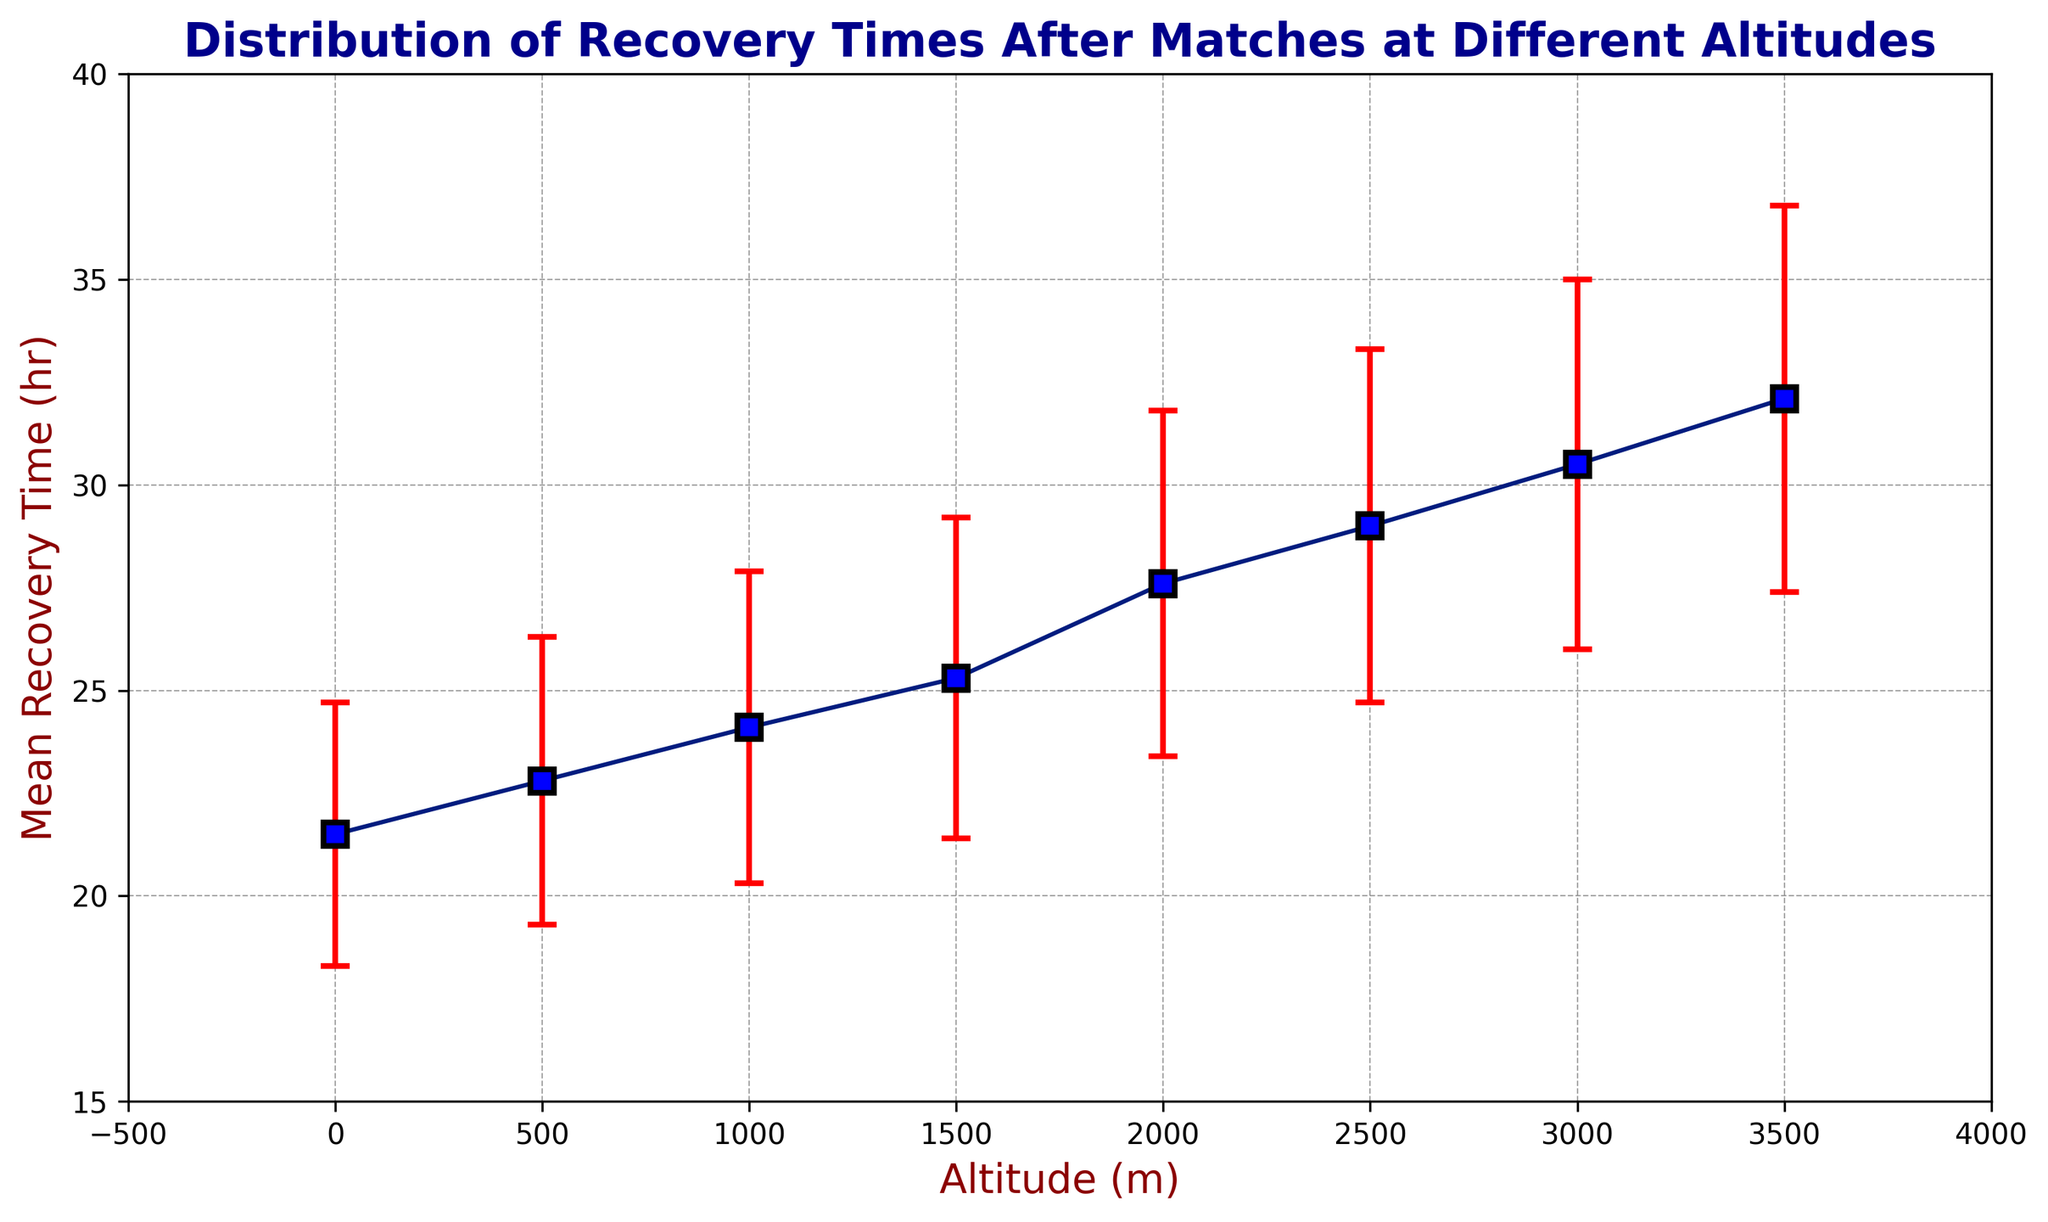What's the mean recovery time at 2000m altitude? The mean recovery time for 2000m altitude can be found by locating the corresponding point on the plot. Refer to the y-axis value for 2000m, which is 27.6 hours.
Answer: 27.6 hours How does the recovery time at 0m compare to the recovery time at 3500m? At 0m, the mean recovery time is 21.5 hours. At 3500m, it is 32.1 hours. The comparison shows that the recovery time at 3500m is significantly higher.
Answer: 3500m > 0m What is the difference in mean recovery time between 1000m and 3000m altitudes? The mean recovery time at 1000m is 24.1 hours, and at 3000m it is 30.5 hours. Subtract 24.1 from 30.5: 30.5 - 24.1 = 6.4 hours.
Answer: 6.4 hours At which altitude is the recovery time between 24 and 25 hours? Scan the y-axis for values between 24 and 25 hours and locate the corresponding altitude. At 1000m, the recovery time is 24.1 hours, which fits within this range.
Answer: 1000m What are the minimum and maximum mean recovery times observed on the plot? The lowest mean recovery time is at 0m altitude, which is 21.5 hours. The highest mean recovery time is at 3500m altitude, which is 32.1 hours.
Answer: 21.5 hours (min), 32.1 hours (max) How does the trend of recovery times change as altitude increases? Observing the plot, mean recovery times increase steadily as altitude increases from 0m to 3500m, indicating a positive correlation.
Answer: Increases What is the mean recovery time at the altitude with the highest error margin? The highest standard deviation (error margin) is observed at 3500m with a value of 4.7 hours. The mean recovery time at this altitude is 32.1 hours.
Answer: 32.1 hours Which two consecutive altitudes have the smallest increase in recovery time? Compare the differences between consecutive mean recovery times: 0m-500m (1.3), 500m-1000m (1.3), 1000m-1500m (1.2), 1500m-2000m (2.3), 2000m-2500m (1.4), 2500m-3000m (1.5), 3000m-3500m (1.6). The smallest increase is between 1000m and 1500m (1.2 hours).
Answer: 1000m - 1500m Considering the entire altitude range, what is the average mean recovery time? Average mean recovery time: (21.5 + 22.8 + 24.1 + 25.3 + 27.6 + 29.0 + 30.5 + 32.1) / 8. Compute the sum, which is 213.9. Divide by 8: 213.9 / 8 = 26.74 hours.
Answer: 26.74 hours 